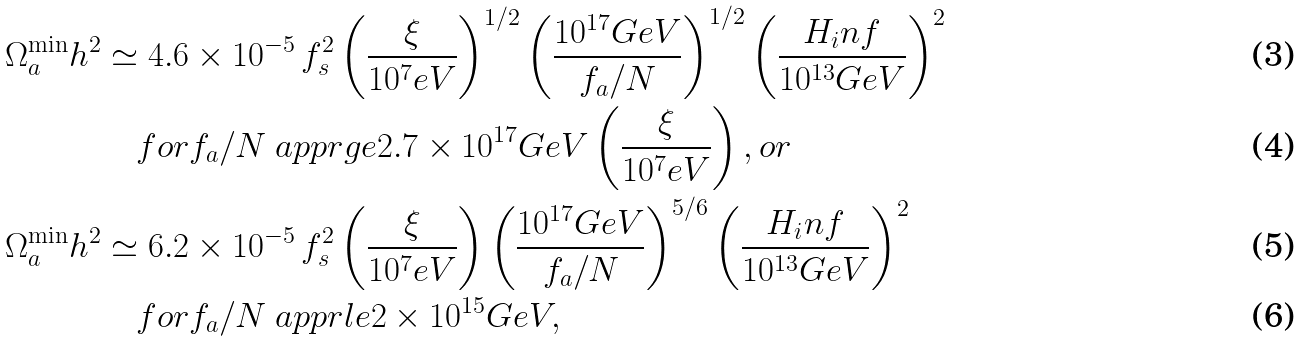Convert formula to latex. <formula><loc_0><loc_0><loc_500><loc_500>\Omega _ { a } ^ { \min } h ^ { 2 } & \simeq 4 . 6 \times 1 0 ^ { - 5 } \, f _ { s } ^ { 2 } \left ( \frac { \xi } { 1 0 ^ { 7 } e V } \right ) ^ { 1 / 2 } \left ( \frac { 1 0 ^ { 1 7 } G e V } { f _ { a } / N } \right ) ^ { 1 / 2 } \left ( \frac { H _ { i } n f } { 1 0 ^ { 1 3 } G e V } \right ) ^ { 2 } \\ & \quad f o r f _ { a } / N \ a p p r g e 2 . 7 \times 1 0 ^ { 1 7 } G e V \left ( \frac { \xi } { 1 0 ^ { 7 } e V } \right ) , o r \\ \Omega _ { a } ^ { \min } h ^ { 2 } & \simeq 6 . 2 \times 1 0 ^ { - 5 } \, f _ { s } ^ { 2 } \left ( \frac { \xi } { 1 0 ^ { 7 } e V } \right ) \left ( \frac { 1 0 ^ { 1 7 } G e V } { f _ { a } / N } \right ) ^ { 5 / 6 } \left ( \frac { H _ { i } n f } { 1 0 ^ { 1 3 } G e V } \right ) ^ { 2 } \\ & \quad f o r f _ { a } / N \ a p p r l e 2 \times 1 0 ^ { 1 5 } G e V ,</formula> 